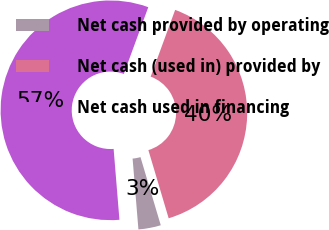<chart> <loc_0><loc_0><loc_500><loc_500><pie_chart><fcel>Net cash provided by operating<fcel>Net cash (used in) provided by<fcel>Net cash used in financing<nl><fcel>3.3%<fcel>39.8%<fcel>56.9%<nl></chart> 